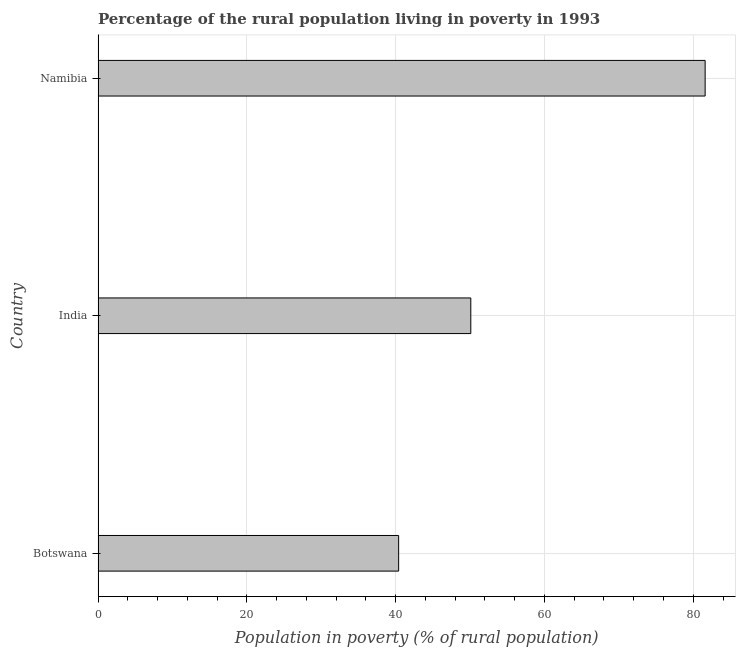What is the title of the graph?
Ensure brevity in your answer.  Percentage of the rural population living in poverty in 1993. What is the label or title of the X-axis?
Ensure brevity in your answer.  Population in poverty (% of rural population). What is the label or title of the Y-axis?
Ensure brevity in your answer.  Country. What is the percentage of rural population living below poverty line in Botswana?
Make the answer very short. 40.4. Across all countries, what is the maximum percentage of rural population living below poverty line?
Ensure brevity in your answer.  81.6. Across all countries, what is the minimum percentage of rural population living below poverty line?
Offer a very short reply. 40.4. In which country was the percentage of rural population living below poverty line maximum?
Your answer should be very brief. Namibia. In which country was the percentage of rural population living below poverty line minimum?
Give a very brief answer. Botswana. What is the sum of the percentage of rural population living below poverty line?
Keep it short and to the point. 172.1. What is the difference between the percentage of rural population living below poverty line in India and Namibia?
Offer a terse response. -31.5. What is the average percentage of rural population living below poverty line per country?
Give a very brief answer. 57.37. What is the median percentage of rural population living below poverty line?
Make the answer very short. 50.1. What is the ratio of the percentage of rural population living below poverty line in Botswana to that in Namibia?
Offer a terse response. 0.49. Is the difference between the percentage of rural population living below poverty line in Botswana and Namibia greater than the difference between any two countries?
Keep it short and to the point. Yes. What is the difference between the highest and the second highest percentage of rural population living below poverty line?
Make the answer very short. 31.5. What is the difference between the highest and the lowest percentage of rural population living below poverty line?
Offer a very short reply. 41.2. In how many countries, is the percentage of rural population living below poverty line greater than the average percentage of rural population living below poverty line taken over all countries?
Provide a short and direct response. 1. Are all the bars in the graph horizontal?
Provide a short and direct response. Yes. Are the values on the major ticks of X-axis written in scientific E-notation?
Offer a terse response. No. What is the Population in poverty (% of rural population) of Botswana?
Your answer should be very brief. 40.4. What is the Population in poverty (% of rural population) of India?
Your answer should be compact. 50.1. What is the Population in poverty (% of rural population) of Namibia?
Your answer should be very brief. 81.6. What is the difference between the Population in poverty (% of rural population) in Botswana and India?
Make the answer very short. -9.7. What is the difference between the Population in poverty (% of rural population) in Botswana and Namibia?
Your response must be concise. -41.2. What is the difference between the Population in poverty (% of rural population) in India and Namibia?
Your answer should be compact. -31.5. What is the ratio of the Population in poverty (% of rural population) in Botswana to that in India?
Keep it short and to the point. 0.81. What is the ratio of the Population in poverty (% of rural population) in Botswana to that in Namibia?
Make the answer very short. 0.49. What is the ratio of the Population in poverty (% of rural population) in India to that in Namibia?
Ensure brevity in your answer.  0.61. 